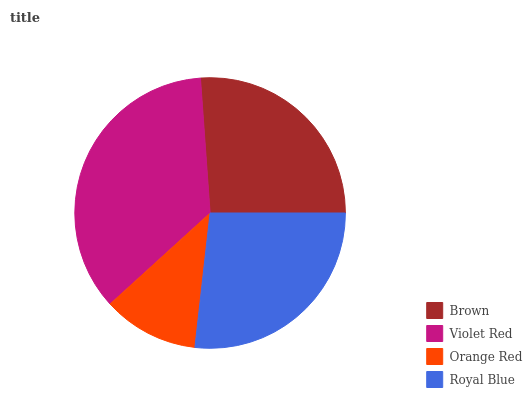Is Orange Red the minimum?
Answer yes or no. Yes. Is Violet Red the maximum?
Answer yes or no. Yes. Is Violet Red the minimum?
Answer yes or no. No. Is Orange Red the maximum?
Answer yes or no. No. Is Violet Red greater than Orange Red?
Answer yes or no. Yes. Is Orange Red less than Violet Red?
Answer yes or no. Yes. Is Orange Red greater than Violet Red?
Answer yes or no. No. Is Violet Red less than Orange Red?
Answer yes or no. No. Is Royal Blue the high median?
Answer yes or no. Yes. Is Brown the low median?
Answer yes or no. Yes. Is Brown the high median?
Answer yes or no. No. Is Orange Red the low median?
Answer yes or no. No. 